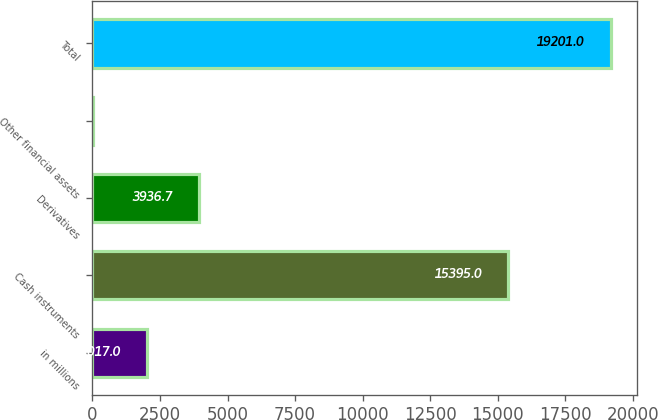<chart> <loc_0><loc_0><loc_500><loc_500><bar_chart><fcel>in millions<fcel>Cash instruments<fcel>Derivatives<fcel>Other financial assets<fcel>Total<nl><fcel>2017<fcel>15395<fcel>3936.7<fcel>4<fcel>19201<nl></chart> 